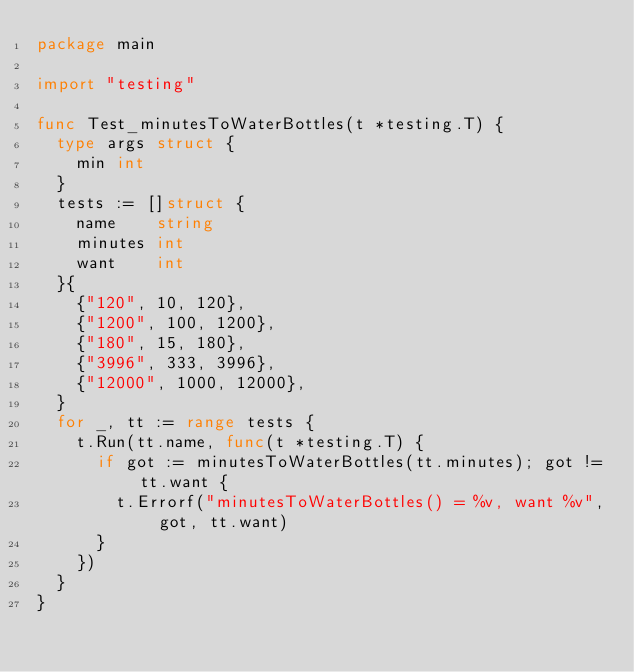Convert code to text. <code><loc_0><loc_0><loc_500><loc_500><_Go_>package main

import "testing"

func Test_minutesToWaterBottles(t *testing.T) {
	type args struct {
		min int
	}
	tests := []struct {
		name    string
		minutes int
		want    int
	}{
		{"120", 10, 120},
		{"1200", 100, 1200},
		{"180", 15, 180},
		{"3996", 333, 3996},
		{"12000", 1000, 12000},
	}
	for _, tt := range tests {
		t.Run(tt.name, func(t *testing.T) {
			if got := minutesToWaterBottles(tt.minutes); got != tt.want {
				t.Errorf("minutesToWaterBottles() = %v, want %v", got, tt.want)
			}
		})
	}
}
</code> 